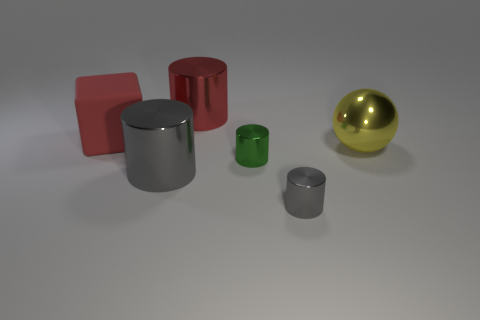Can you describe the sizes of the objects relative to each other? Certainly, the large red block and the silver cylinders are the most prominent, with the large cylinder being the tallest. The red cylinder is intermediate in size, and the green cylinder and the sphere are the smallest. The sphere's size is closer to that of the green cylinder, and it's the only object with a completely rounded shape, which makes it stand out. 